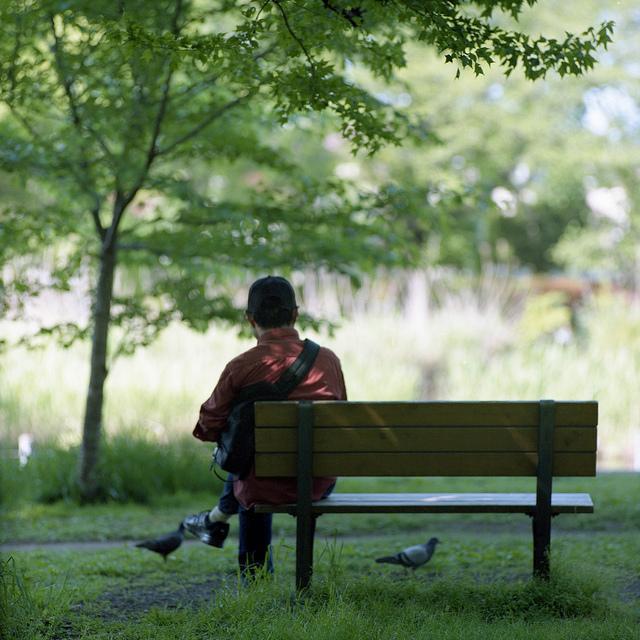How many birds are there?
Give a very brief answer. 2. How many chairs are there?
Give a very brief answer. 1. How many people are pictured?
Give a very brief answer. 1. How many benches are pictured?
Give a very brief answer. 1. How many benches are there?
Give a very brief answer. 1. How many backpacks are there?
Give a very brief answer. 1. 